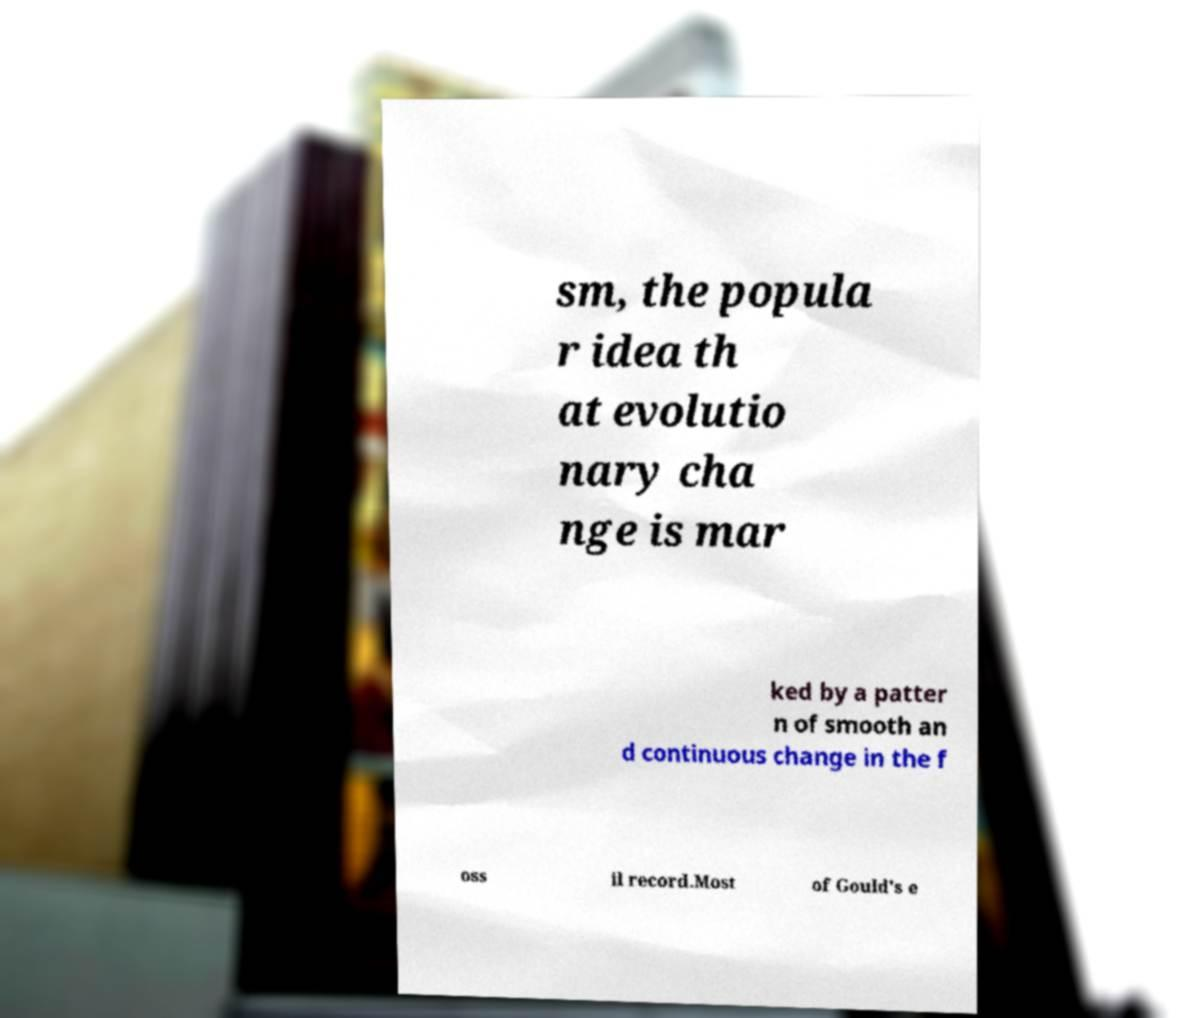I need the written content from this picture converted into text. Can you do that? sm, the popula r idea th at evolutio nary cha nge is mar ked by a patter n of smooth an d continuous change in the f oss il record.Most of Gould's e 